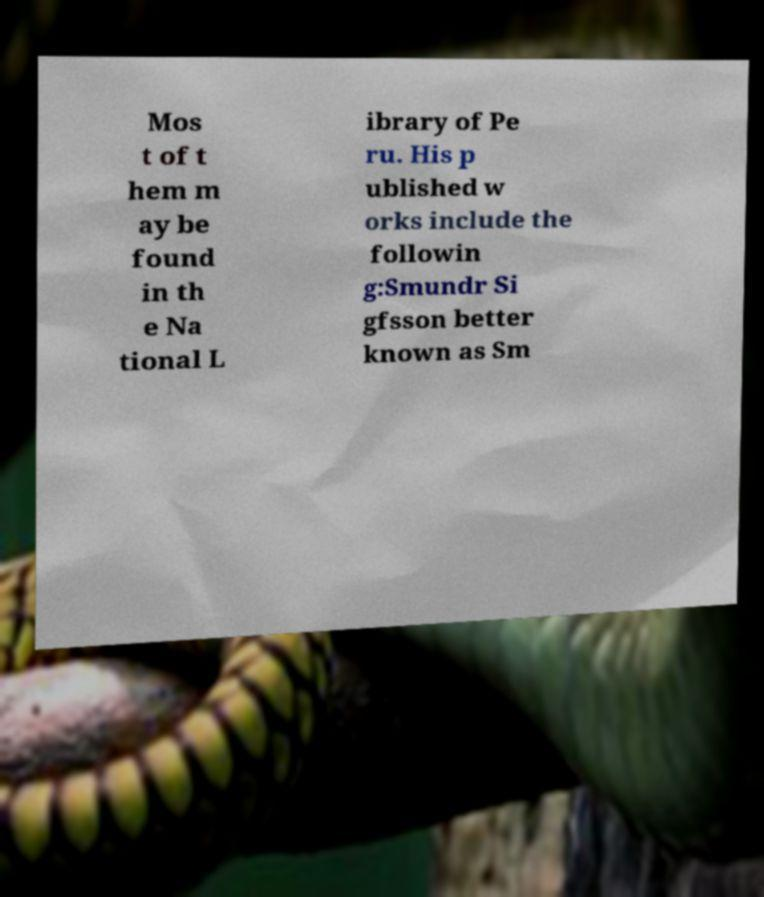Can you read and provide the text displayed in the image?This photo seems to have some interesting text. Can you extract and type it out for me? Mos t of t hem m ay be found in th e Na tional L ibrary of Pe ru. His p ublished w orks include the followin g:Smundr Si gfsson better known as Sm 